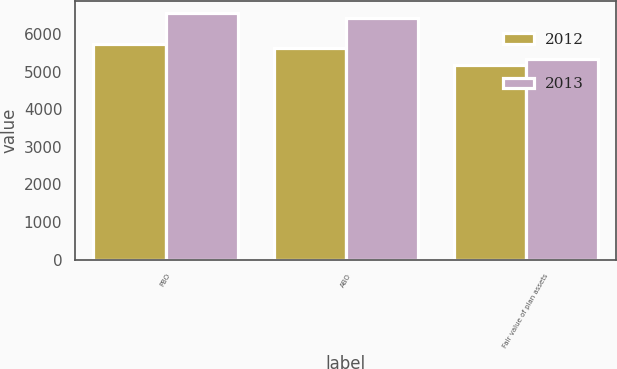Convert chart to OTSL. <chart><loc_0><loc_0><loc_500><loc_500><stacked_bar_chart><ecel><fcel>PBO<fcel>ABO<fcel>Fair value of plan assets<nl><fcel>2012<fcel>5722<fcel>5622<fcel>5163<nl><fcel>2013<fcel>6558<fcel>6440<fcel>5335<nl></chart> 